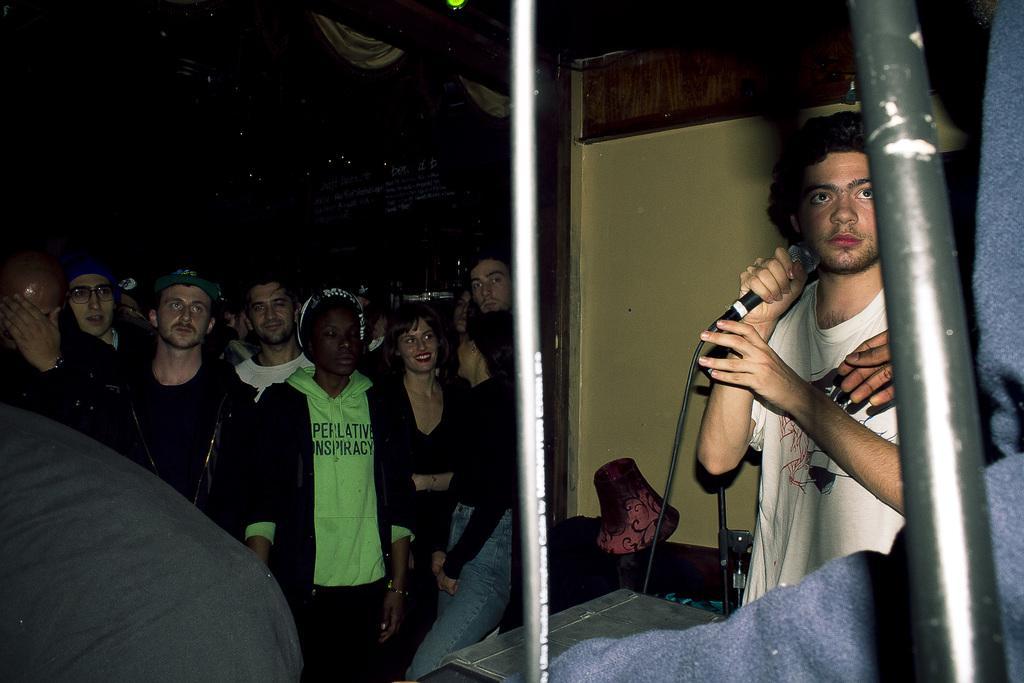Can you describe this image briefly? In this image, we can see people and some are wearing caps and one of them is holding a mic and we can see some rods, stands and there is a wall. 